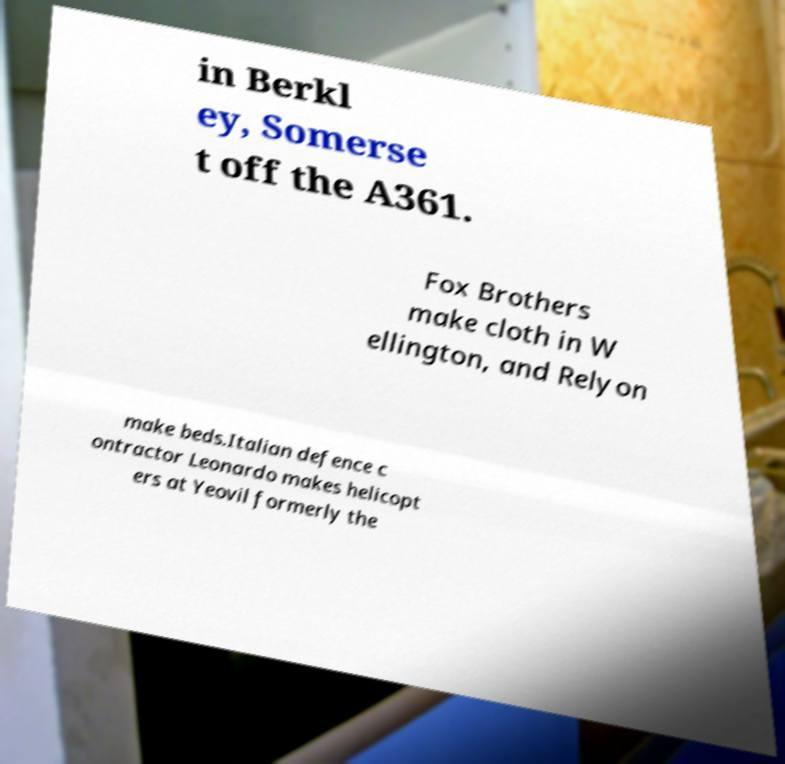There's text embedded in this image that I need extracted. Can you transcribe it verbatim? in Berkl ey, Somerse t off the A361. Fox Brothers make cloth in W ellington, and Relyon make beds.Italian defence c ontractor Leonardo makes helicopt ers at Yeovil formerly the 